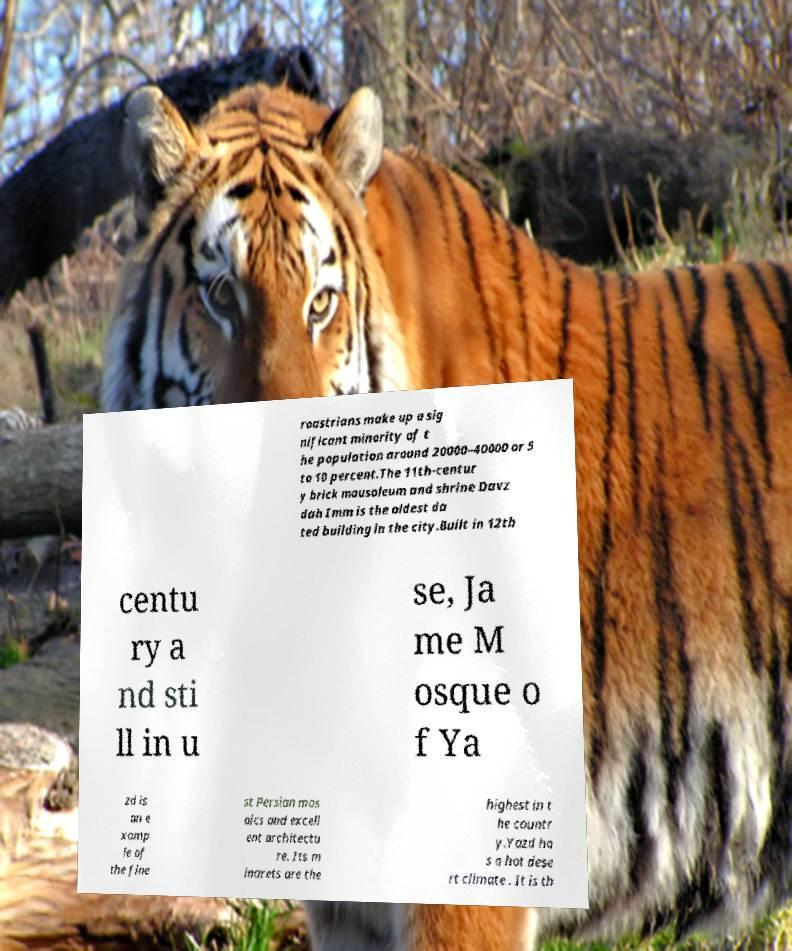Can you read and provide the text displayed in the image?This photo seems to have some interesting text. Can you extract and type it out for me? roastrians make up a sig nificant minority of t he population around 20000–40000 or 5 to 10 percent.The 11th-centur y brick mausoleum and shrine Davz dah Imm is the oldest da ted building in the city.Built in 12th centu ry a nd sti ll in u se, Ja me M osque o f Ya zd is an e xamp le of the fine st Persian mos aics and excell ent architectu re. Its m inarets are the highest in t he countr y.Yazd ha s a hot dese rt climate . It is th 